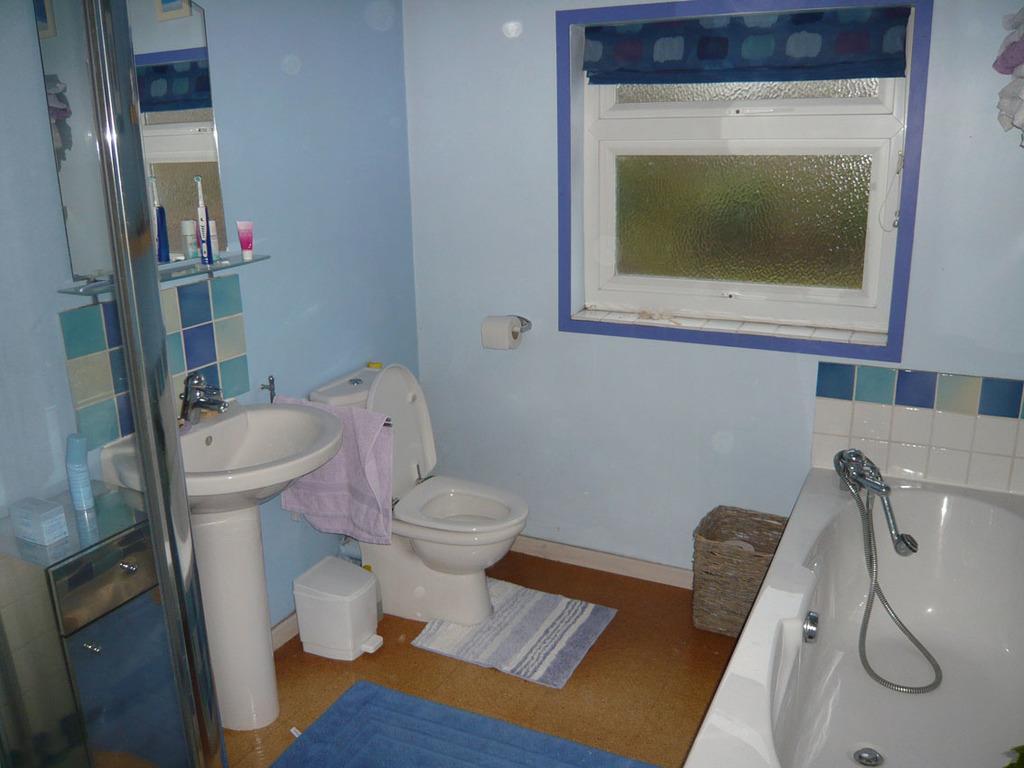Please provide a concise description of this image. This image is clicked inside a washroom. In the center there is a western toilet seat. Beside to it there is a wash basin. Above the wash basin there is a mirror. There are creams near to the mirror. Beside the wash basin there is a glass door. On the other side of the door there is a metal table. There is a bottle on the table. There are mats on the floor. To the right there is a bathtub. There is a wall in the image. In the center there is a window to the wall. 